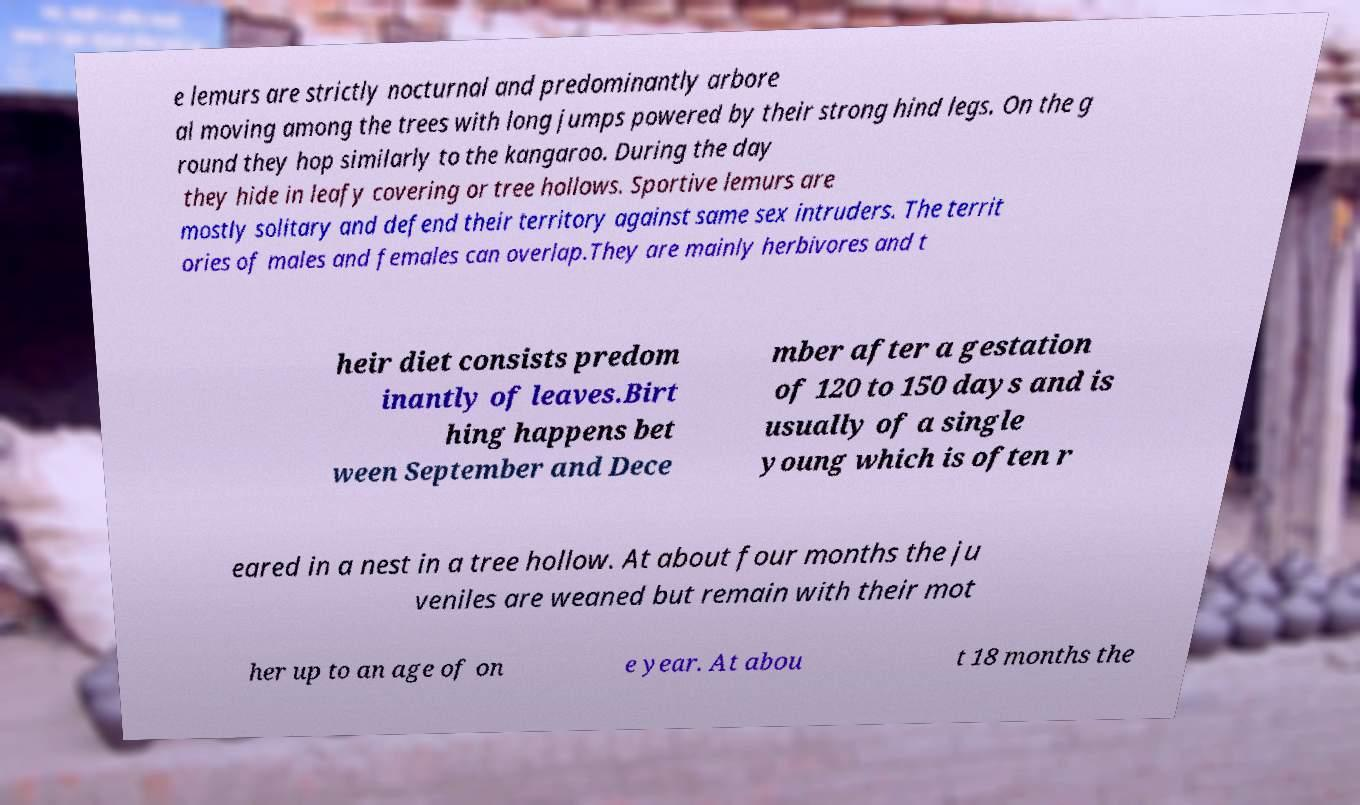For documentation purposes, I need the text within this image transcribed. Could you provide that? e lemurs are strictly nocturnal and predominantly arbore al moving among the trees with long jumps powered by their strong hind legs. On the g round they hop similarly to the kangaroo. During the day they hide in leafy covering or tree hollows. Sportive lemurs are mostly solitary and defend their territory against same sex intruders. The territ ories of males and females can overlap.They are mainly herbivores and t heir diet consists predom inantly of leaves.Birt hing happens bet ween September and Dece mber after a gestation of 120 to 150 days and is usually of a single young which is often r eared in a nest in a tree hollow. At about four months the ju veniles are weaned but remain with their mot her up to an age of on e year. At abou t 18 months the 